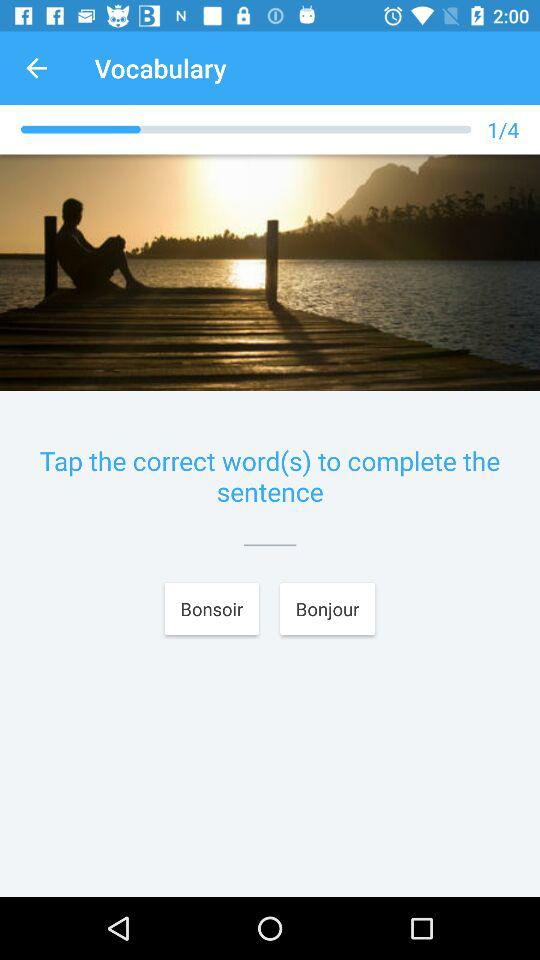Which vocabulary number is selected currently? The vocabulary number currently selected is 1. 